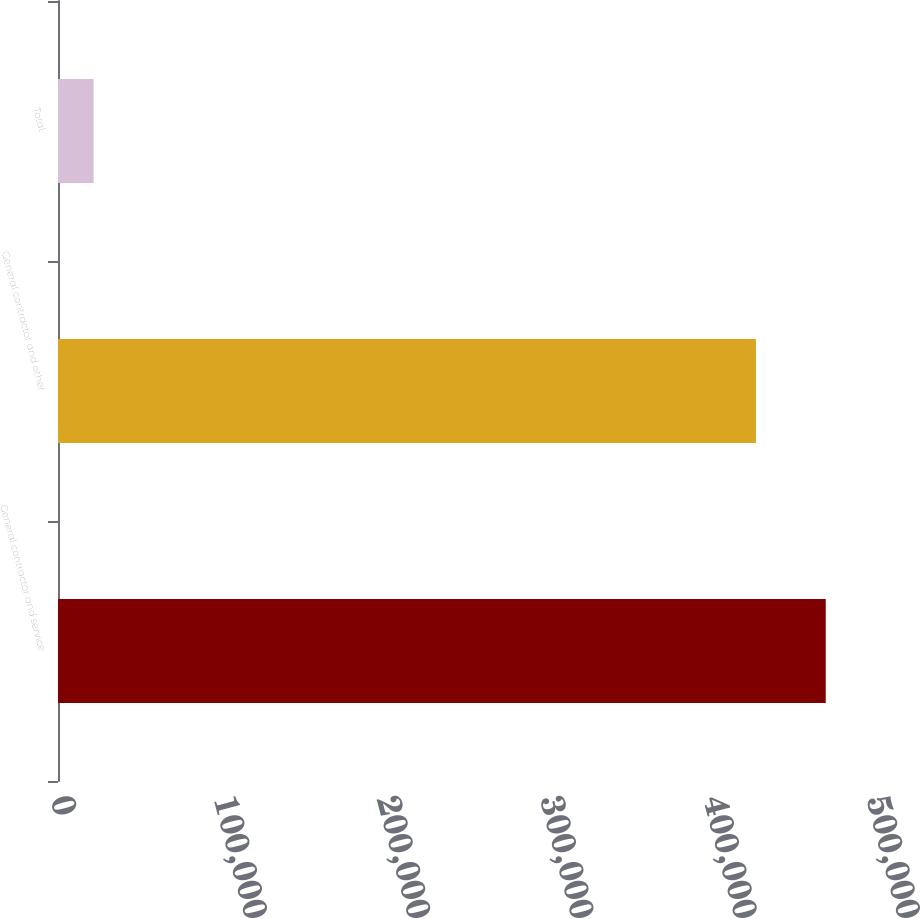Convert chart to OTSL. <chart><loc_0><loc_0><loc_500><loc_500><bar_chart><fcel>General contractor and service<fcel>General contractor and other<fcel>Total<nl><fcel>470433<fcel>427666<fcel>21843<nl></chart> 